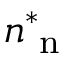<formula> <loc_0><loc_0><loc_500><loc_500>n _ { n } ^ { \ast }</formula> 